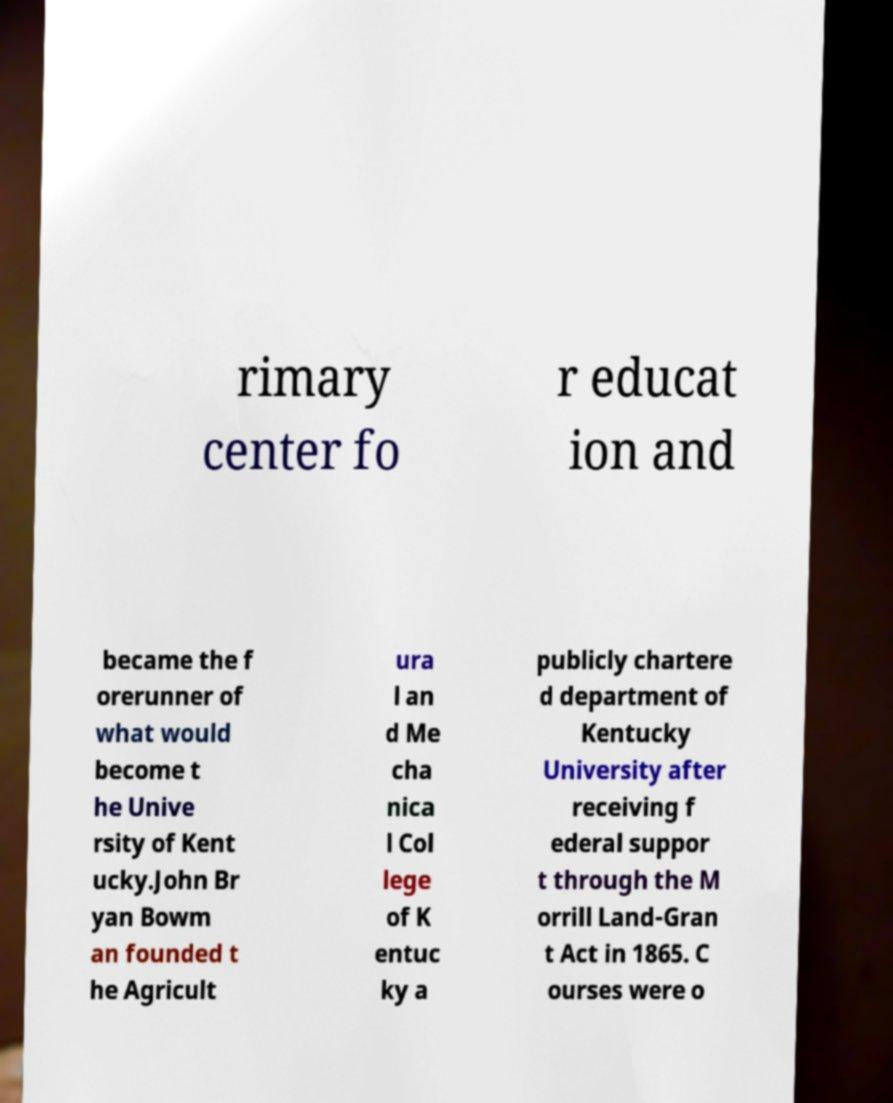Can you accurately transcribe the text from the provided image for me? rimary center fo r educat ion and became the f orerunner of what would become t he Unive rsity of Kent ucky.John Br yan Bowm an founded t he Agricult ura l an d Me cha nica l Col lege of K entuc ky a publicly chartere d department of Kentucky University after receiving f ederal suppor t through the M orrill Land-Gran t Act in 1865. C ourses were o 